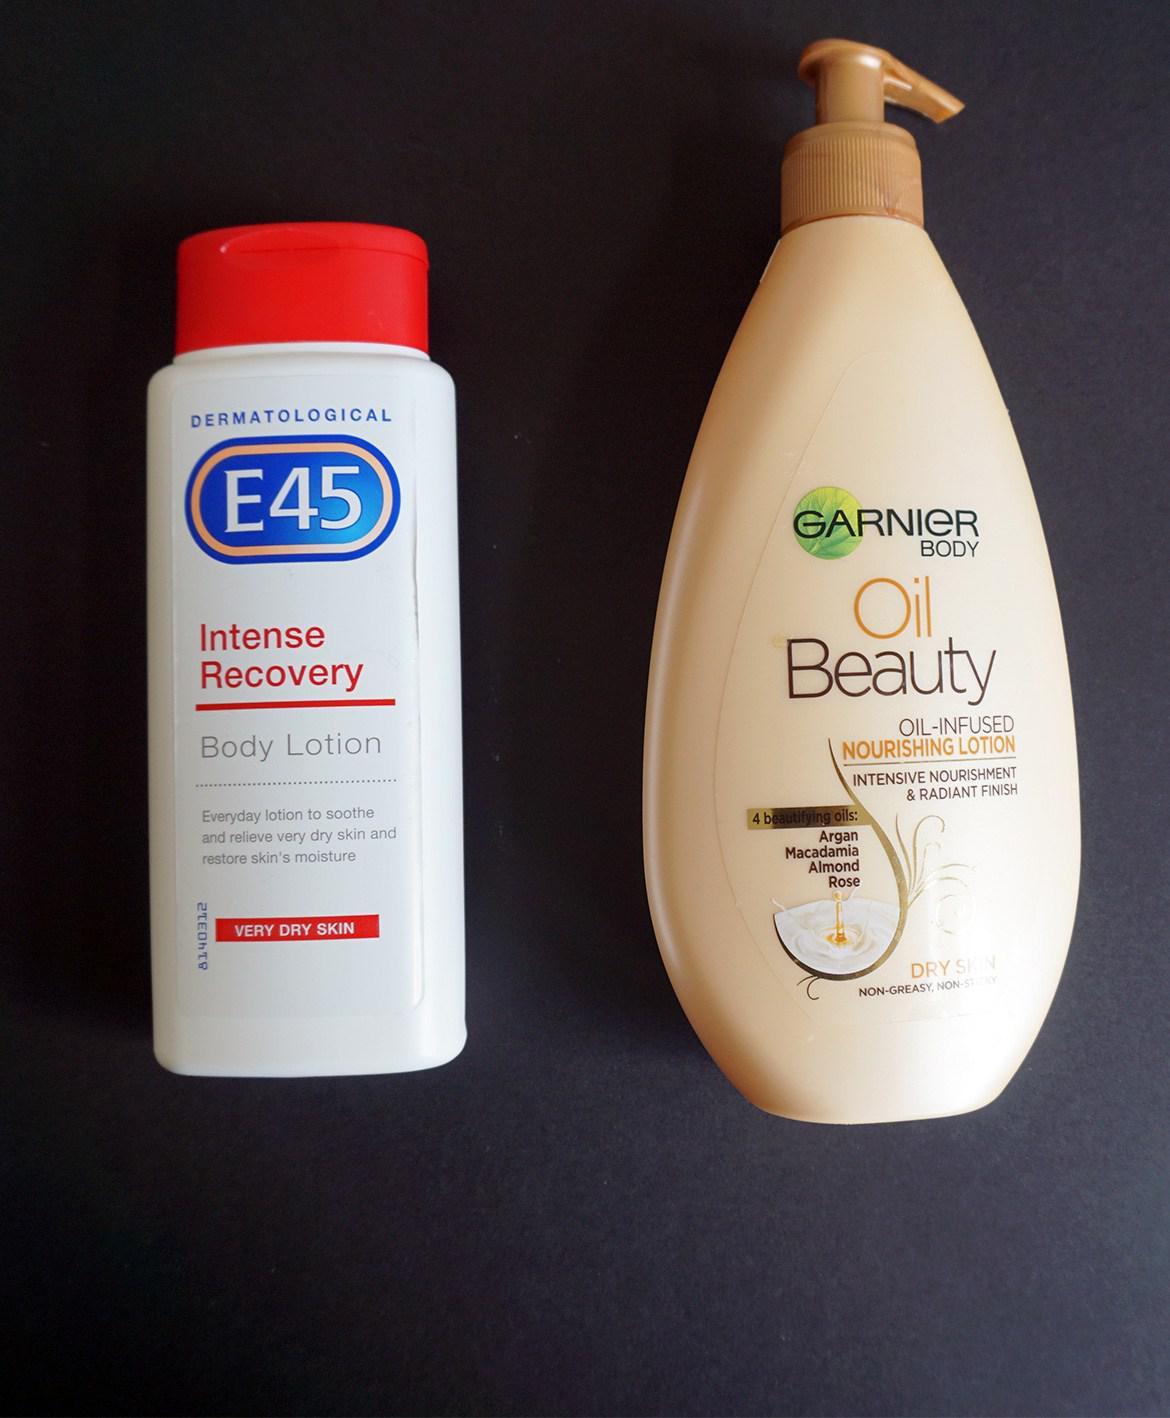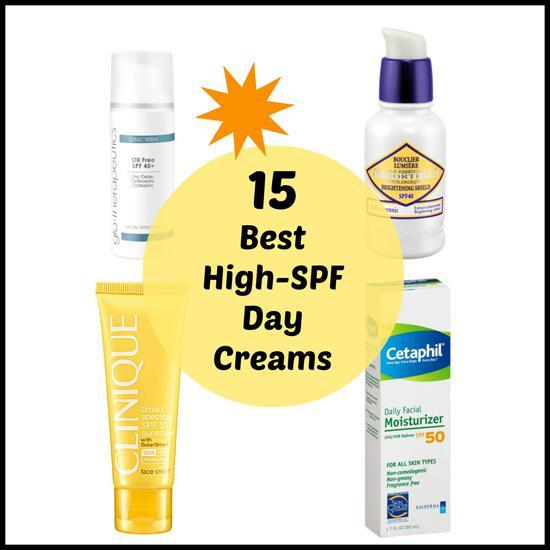The first image is the image on the left, the second image is the image on the right. For the images displayed, is the sentence "The left image contains no more than two skincare products, and includes at least one pump-top bottle with its nozzle facing rightward." factually correct? Answer yes or no. Yes. The first image is the image on the left, the second image is the image on the right. Analyze the images presented: Is the assertion "The left image contains at least two ointment containers." valid? Answer yes or no. Yes. 